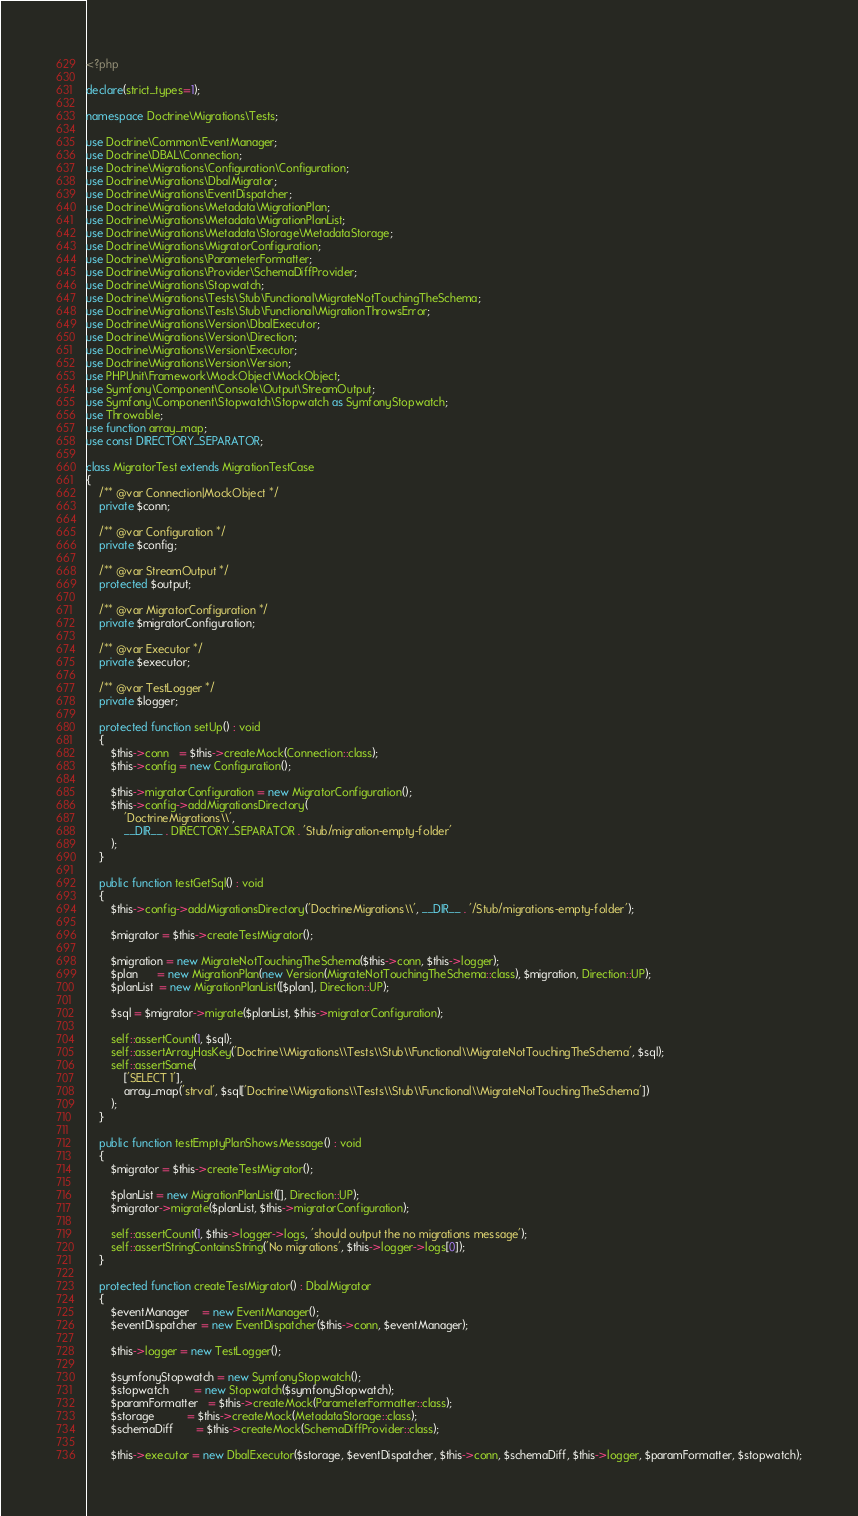<code> <loc_0><loc_0><loc_500><loc_500><_PHP_><?php

declare(strict_types=1);

namespace Doctrine\Migrations\Tests;

use Doctrine\Common\EventManager;
use Doctrine\DBAL\Connection;
use Doctrine\Migrations\Configuration\Configuration;
use Doctrine\Migrations\DbalMigrator;
use Doctrine\Migrations\EventDispatcher;
use Doctrine\Migrations\Metadata\MigrationPlan;
use Doctrine\Migrations\Metadata\MigrationPlanList;
use Doctrine\Migrations\Metadata\Storage\MetadataStorage;
use Doctrine\Migrations\MigratorConfiguration;
use Doctrine\Migrations\ParameterFormatter;
use Doctrine\Migrations\Provider\SchemaDiffProvider;
use Doctrine\Migrations\Stopwatch;
use Doctrine\Migrations\Tests\Stub\Functional\MigrateNotTouchingTheSchema;
use Doctrine\Migrations\Tests\Stub\Functional\MigrationThrowsError;
use Doctrine\Migrations\Version\DbalExecutor;
use Doctrine\Migrations\Version\Direction;
use Doctrine\Migrations\Version\Executor;
use Doctrine\Migrations\Version\Version;
use PHPUnit\Framework\MockObject\MockObject;
use Symfony\Component\Console\Output\StreamOutput;
use Symfony\Component\Stopwatch\Stopwatch as SymfonyStopwatch;
use Throwable;
use function array_map;
use const DIRECTORY_SEPARATOR;

class MigratorTest extends MigrationTestCase
{
    /** @var Connection|MockObject */
    private $conn;

    /** @var Configuration */
    private $config;

    /** @var StreamOutput */
    protected $output;

    /** @var MigratorConfiguration */
    private $migratorConfiguration;

    /** @var Executor */
    private $executor;

    /** @var TestLogger */
    private $logger;

    protected function setUp() : void
    {
        $this->conn   = $this->createMock(Connection::class);
        $this->config = new Configuration();

        $this->migratorConfiguration = new MigratorConfiguration();
        $this->config->addMigrationsDirectory(
            'DoctrineMigrations\\',
            __DIR__ . DIRECTORY_SEPARATOR . 'Stub/migration-empty-folder'
        );
    }

    public function testGetSql() : void
    {
        $this->config->addMigrationsDirectory('DoctrineMigrations\\', __DIR__ . '/Stub/migrations-empty-folder');

        $migrator = $this->createTestMigrator();

        $migration = new MigrateNotTouchingTheSchema($this->conn, $this->logger);
        $plan      = new MigrationPlan(new Version(MigrateNotTouchingTheSchema::class), $migration, Direction::UP);
        $planList  = new MigrationPlanList([$plan], Direction::UP);

        $sql = $migrator->migrate($planList, $this->migratorConfiguration);

        self::assertCount(1, $sql);
        self::assertArrayHasKey('Doctrine\\Migrations\\Tests\\Stub\\Functional\\MigrateNotTouchingTheSchema', $sql);
        self::assertSame(
            ['SELECT 1'],
            array_map('strval', $sql['Doctrine\\Migrations\\Tests\\Stub\\Functional\\MigrateNotTouchingTheSchema'])
        );
    }

    public function testEmptyPlanShowsMessage() : void
    {
        $migrator = $this->createTestMigrator();

        $planList = new MigrationPlanList([], Direction::UP);
        $migrator->migrate($planList, $this->migratorConfiguration);

        self::assertCount(1, $this->logger->logs, 'should output the no migrations message');
        self::assertStringContainsString('No migrations', $this->logger->logs[0]);
    }

    protected function createTestMigrator() : DbalMigrator
    {
        $eventManager    = new EventManager();
        $eventDispatcher = new EventDispatcher($this->conn, $eventManager);

        $this->logger = new TestLogger();

        $symfonyStopwatch = new SymfonyStopwatch();
        $stopwatch        = new Stopwatch($symfonyStopwatch);
        $paramFormatter   = $this->createMock(ParameterFormatter::class);
        $storage          = $this->createMock(MetadataStorage::class);
        $schemaDiff       = $this->createMock(SchemaDiffProvider::class);

        $this->executor = new DbalExecutor($storage, $eventDispatcher, $this->conn, $schemaDiff, $this->logger, $paramFormatter, $stopwatch);
</code> 